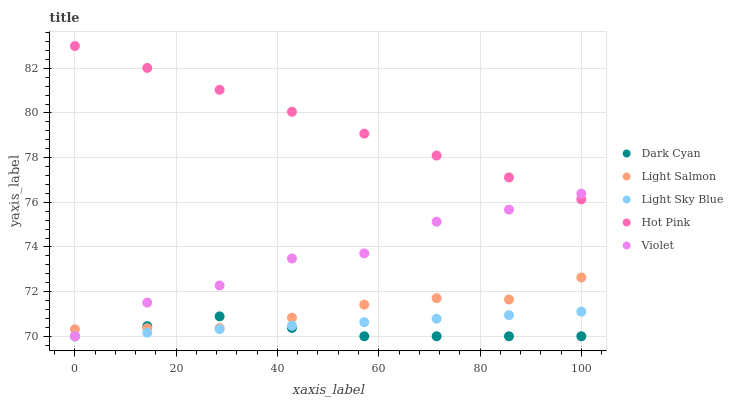Does Dark Cyan have the minimum area under the curve?
Answer yes or no. Yes. Does Hot Pink have the maximum area under the curve?
Answer yes or no. Yes. Does Violet have the minimum area under the curve?
Answer yes or no. No. Does Violet have the maximum area under the curve?
Answer yes or no. No. Is Hot Pink the smoothest?
Answer yes or no. Yes. Is Violet the roughest?
Answer yes or no. Yes. Is Light Salmon the smoothest?
Answer yes or no. No. Is Light Salmon the roughest?
Answer yes or no. No. Does Dark Cyan have the lowest value?
Answer yes or no. Yes. Does Light Salmon have the lowest value?
Answer yes or no. No. Does Hot Pink have the highest value?
Answer yes or no. Yes. Does Violet have the highest value?
Answer yes or no. No. Is Light Sky Blue less than Hot Pink?
Answer yes or no. Yes. Is Hot Pink greater than Light Salmon?
Answer yes or no. Yes. Does Violet intersect Light Salmon?
Answer yes or no. Yes. Is Violet less than Light Salmon?
Answer yes or no. No. Is Violet greater than Light Salmon?
Answer yes or no. No. Does Light Sky Blue intersect Hot Pink?
Answer yes or no. No. 